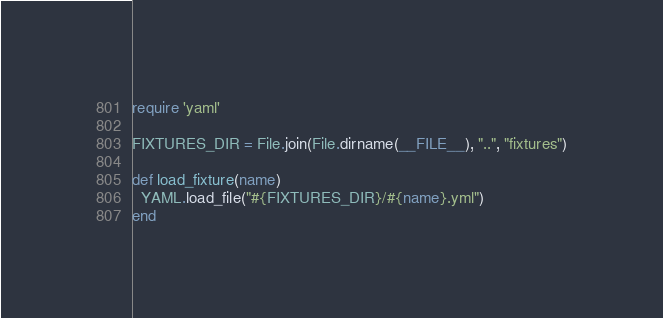<code> <loc_0><loc_0><loc_500><loc_500><_Ruby_>require 'yaml'

FIXTURES_DIR = File.join(File.dirname(__FILE__), "..", "fixtures")

def load_fixture(name)
  YAML.load_file("#{FIXTURES_DIR}/#{name}.yml")
end
</code> 